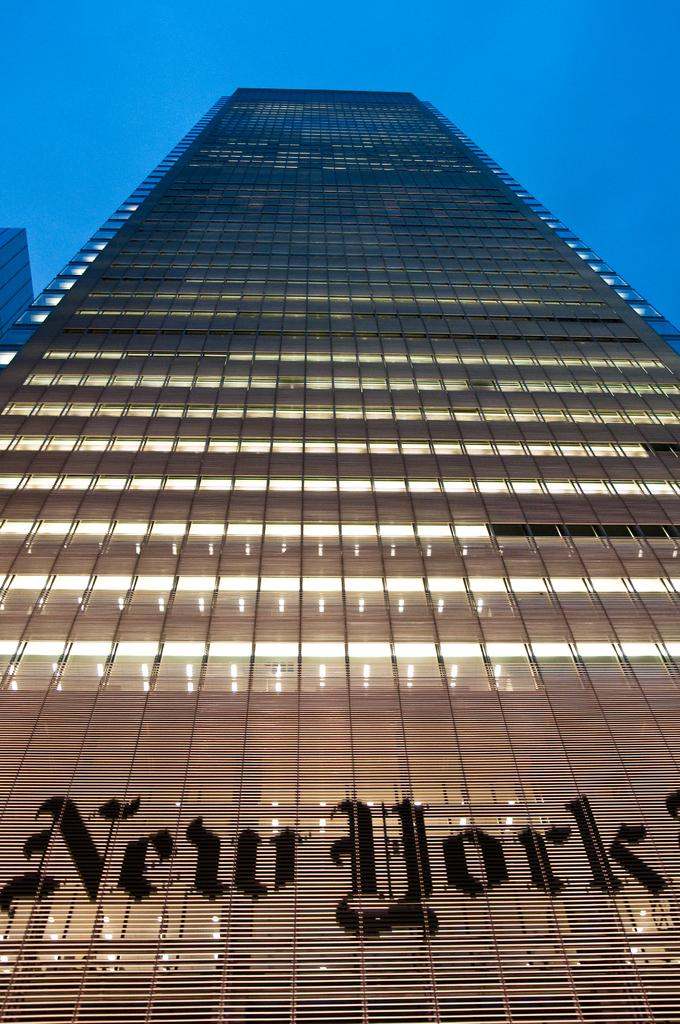What is the main subject of the image? The main subject of the image is a building. Can you describe the building in the image? The building has many lights all over it. What can be seen above the building in the image? The sky is visible above the building. How many tickets does the baby have in the image? There is no baby or tickets present in the image. 